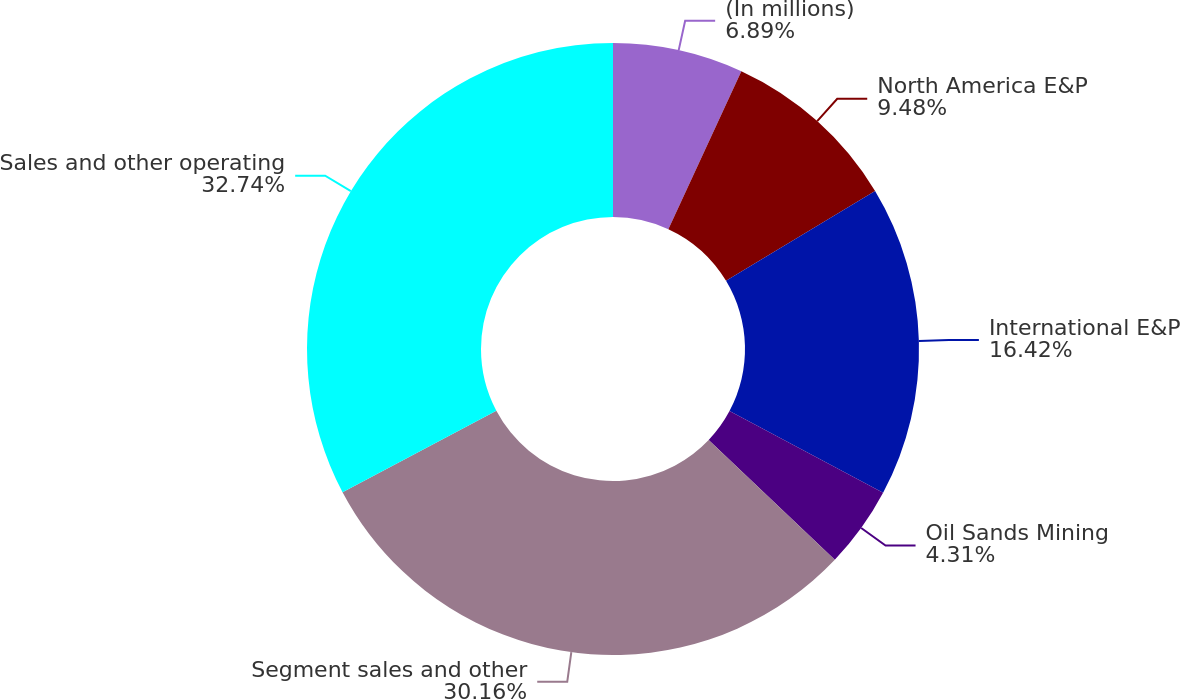Convert chart. <chart><loc_0><loc_0><loc_500><loc_500><pie_chart><fcel>(In millions)<fcel>North America E&P<fcel>International E&P<fcel>Oil Sands Mining<fcel>Segment sales and other<fcel>Sales and other operating<nl><fcel>6.89%<fcel>9.48%<fcel>16.42%<fcel>4.31%<fcel>30.16%<fcel>32.75%<nl></chart> 